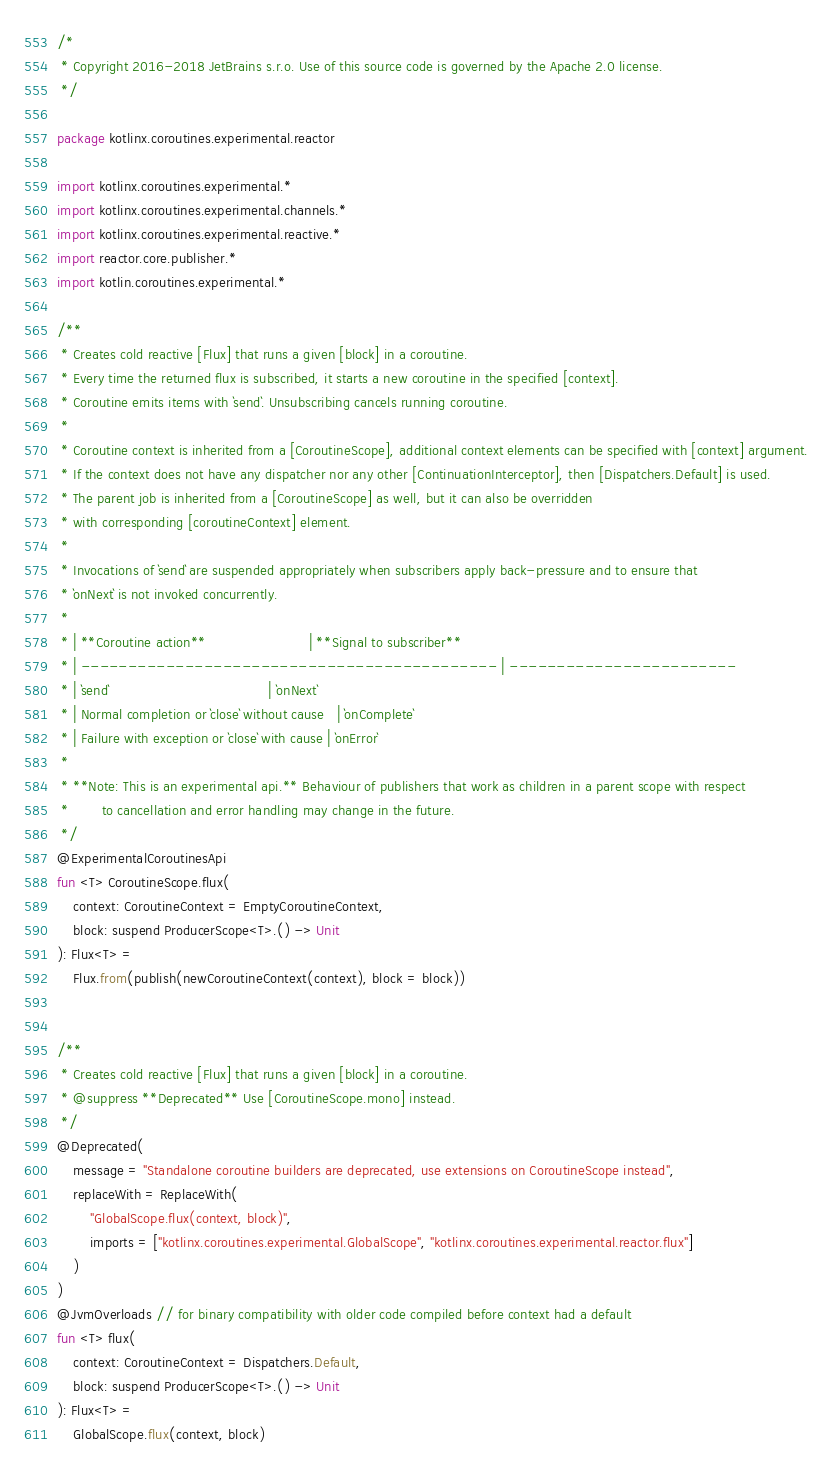<code> <loc_0><loc_0><loc_500><loc_500><_Kotlin_>/*
 * Copyright 2016-2018 JetBrains s.r.o. Use of this source code is governed by the Apache 2.0 license.
 */

package kotlinx.coroutines.experimental.reactor

import kotlinx.coroutines.experimental.*
import kotlinx.coroutines.experimental.channels.*
import kotlinx.coroutines.experimental.reactive.*
import reactor.core.publisher.*
import kotlin.coroutines.experimental.*

/**
 * Creates cold reactive [Flux] that runs a given [block] in a coroutine.
 * Every time the returned flux is subscribed, it starts a new coroutine in the specified [context].
 * Coroutine emits items with `send`. Unsubscribing cancels running coroutine.
 *
 * Coroutine context is inherited from a [CoroutineScope], additional context elements can be specified with [context] argument.
 * If the context does not have any dispatcher nor any other [ContinuationInterceptor], then [Dispatchers.Default] is used.
 * The parent job is inherited from a [CoroutineScope] as well, but it can also be overridden
 * with corresponding [coroutineContext] element.
 *
 * Invocations of `send` are suspended appropriately when subscribers apply back-pressure and to ensure that
 * `onNext` is not invoked concurrently.
 *
 * | **Coroutine action**                         | **Signal to subscriber**
 * | -------------------------------------------- | ------------------------
 * | `send`                                       | `onNext`
 * | Normal completion or `close` without cause   | `onComplete`
 * | Failure with exception or `close` with cause | `onError`
 * 
 * **Note: This is an experimental api.** Behaviour of publishers that work as children in a parent scope with respect
 *        to cancellation and error handling may change in the future.
 */
@ExperimentalCoroutinesApi
fun <T> CoroutineScope.flux(
    context: CoroutineContext = EmptyCoroutineContext,
    block: suspend ProducerScope<T>.() -> Unit
): Flux<T> =
    Flux.from(publish(newCoroutineContext(context), block = block))


/**
 * Creates cold reactive [Flux] that runs a given [block] in a coroutine.
 * @suppress **Deprecated** Use [CoroutineScope.mono] instead.
 */
@Deprecated(
    message = "Standalone coroutine builders are deprecated, use extensions on CoroutineScope instead",
    replaceWith = ReplaceWith(
        "GlobalScope.flux(context, block)",
        imports = ["kotlinx.coroutines.experimental.GlobalScope", "kotlinx.coroutines.experimental.reactor.flux"]
    )
)
@JvmOverloads // for binary compatibility with older code compiled before context had a default
fun <T> flux(
    context: CoroutineContext = Dispatchers.Default,
    block: suspend ProducerScope<T>.() -> Unit
): Flux<T> =
    GlobalScope.flux(context, block)
</code> 